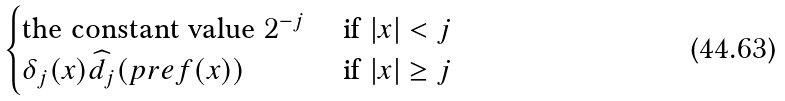Convert formula to latex. <formula><loc_0><loc_0><loc_500><loc_500>\begin{cases} \text {the constant value } 2 ^ { - j } \ & \text {if} \ | x | < j \\ \delta _ { j } ( x ) \widehat { d } _ { j } ( p r e f ( x ) ) \ & \text {if} \ | x | \geq j \end{cases}</formula> 